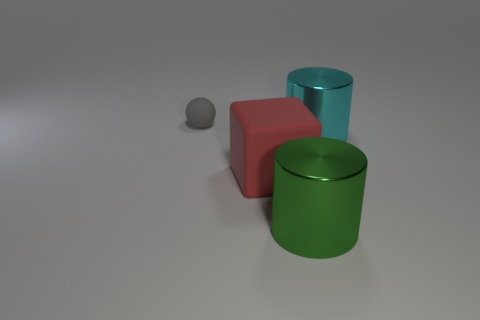Add 3 big blocks. How many objects exist? 7 Subtract all cubes. How many objects are left? 3 Add 2 big blue matte things. How many big blue matte things exist? 2 Subtract 1 red cubes. How many objects are left? 3 Subtract all green cubes. Subtract all small gray spheres. How many objects are left? 3 Add 4 big cyan metal objects. How many big cyan metal objects are left? 5 